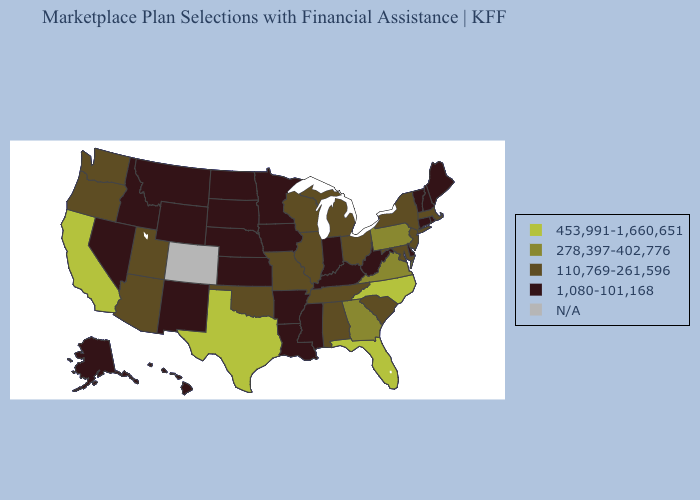Name the states that have a value in the range 278,397-402,776?
Be succinct. Georgia, Pennsylvania, Virginia. Does Maine have the highest value in the Northeast?
Short answer required. No. Among the states that border Oregon , does Nevada have the highest value?
Give a very brief answer. No. What is the highest value in the MidWest ?
Quick response, please. 110,769-261,596. What is the highest value in the Northeast ?
Keep it brief. 278,397-402,776. What is the highest value in the USA?
Write a very short answer. 453,991-1,660,651. What is the highest value in states that border Utah?
Keep it brief. 110,769-261,596. What is the value of Missouri?
Quick response, please. 110,769-261,596. What is the value of Ohio?
Concise answer only. 110,769-261,596. What is the highest value in the MidWest ?
Keep it brief. 110,769-261,596. Does the map have missing data?
Concise answer only. Yes. Among the states that border Kansas , which have the lowest value?
Keep it brief. Nebraska. What is the value of Wisconsin?
Concise answer only. 110,769-261,596. 